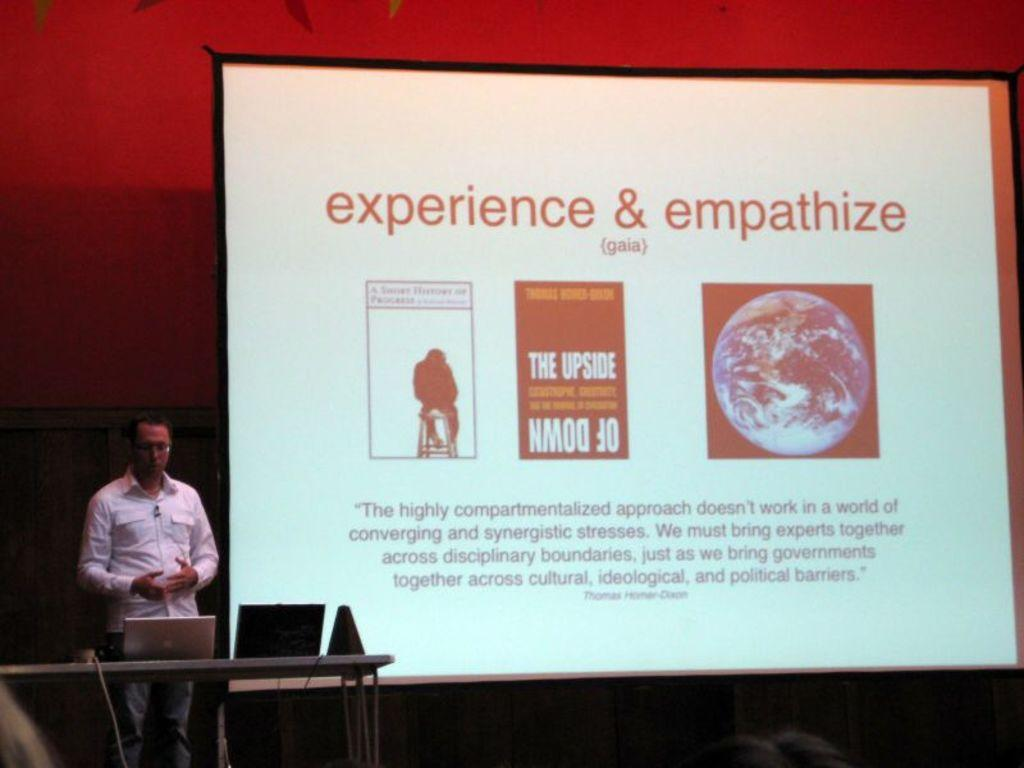<image>
Present a compact description of the photo's key features. A speaker presenting a slide show with the headline experience & emphasize. 